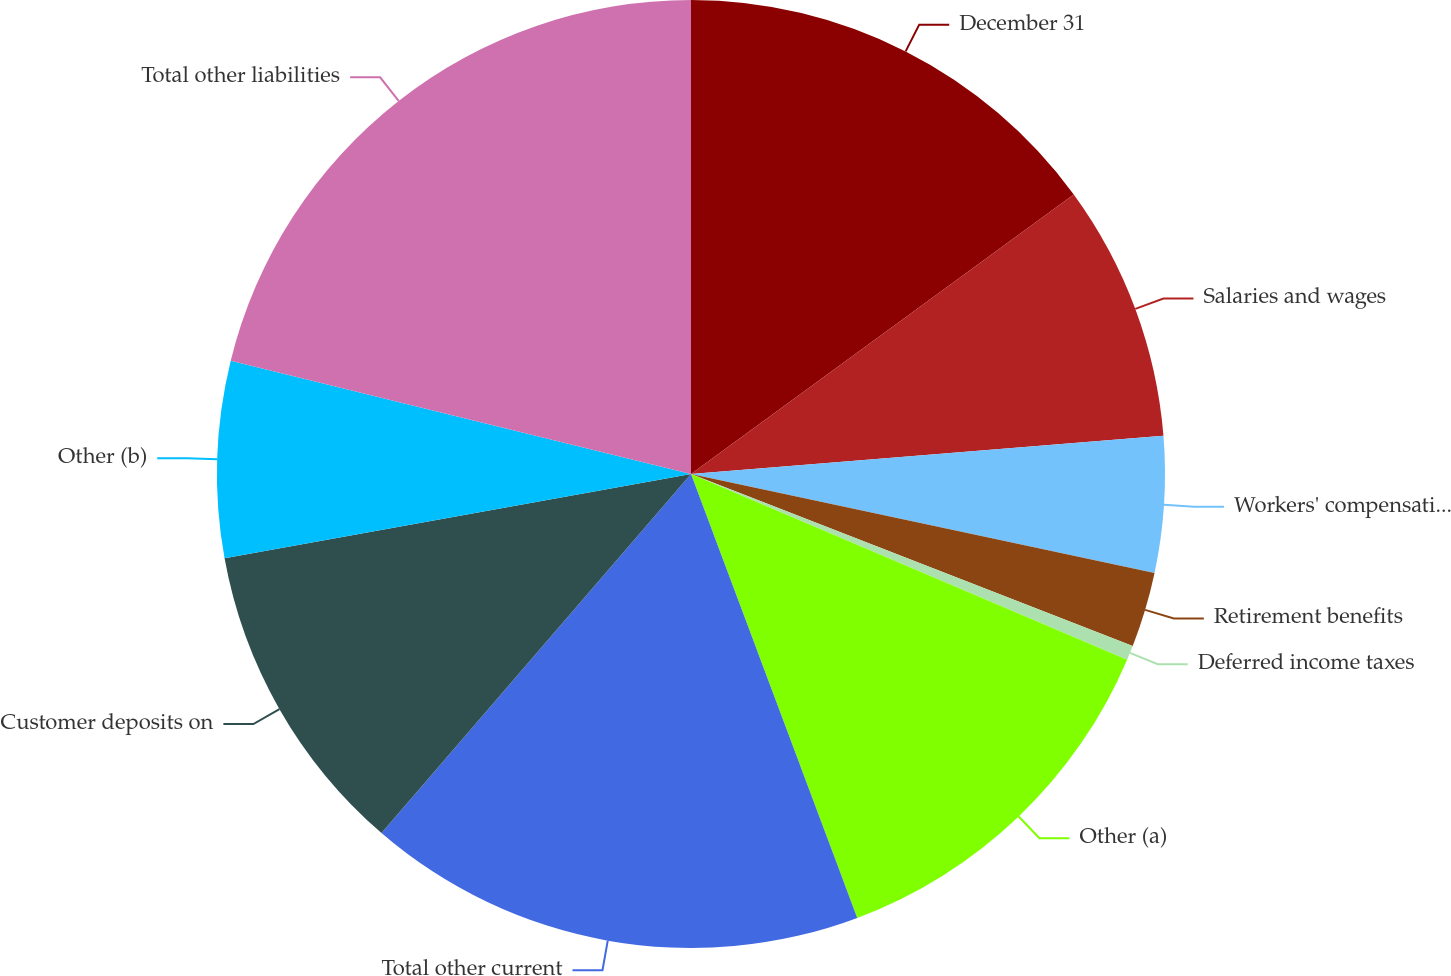Convert chart. <chart><loc_0><loc_0><loc_500><loc_500><pie_chart><fcel>December 31<fcel>Salaries and wages<fcel>Workers' compensation<fcel>Retirement benefits<fcel>Deferred income taxes<fcel>Other (a)<fcel>Total other current<fcel>Customer deposits on<fcel>Other (b)<fcel>Total other liabilities<nl><fcel>14.96%<fcel>8.76%<fcel>4.63%<fcel>2.56%<fcel>0.5%<fcel>12.89%<fcel>17.03%<fcel>10.83%<fcel>6.69%<fcel>21.16%<nl></chart> 